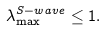Convert formula to latex. <formula><loc_0><loc_0><loc_500><loc_500>\lambda _ { \max } ^ { S - w a v e } \leq 1 .</formula> 